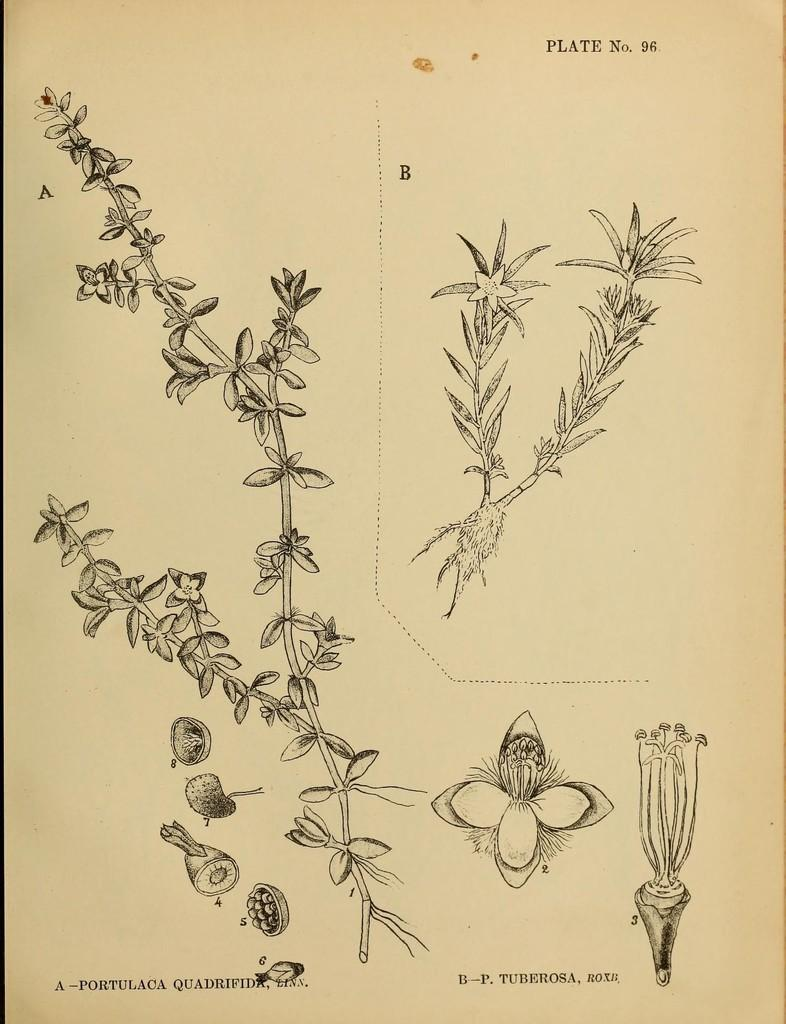What is depicted on the sheet of paper in the image? There is a diagram of a plant on a sheet of paper. What does the diagram show about the plant? The diagram shows the different parts of the plant. How many beads are present on the hill in the image? There are no beads or hills present in the image; it only features a diagram of a plant on a sheet of paper. 